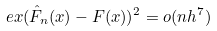<formula> <loc_0><loc_0><loc_500><loc_500>\ e x ( \hat { F } _ { n } ( x ) - F ( x ) ) ^ { 2 } = o ( n h ^ { 7 } )</formula> 